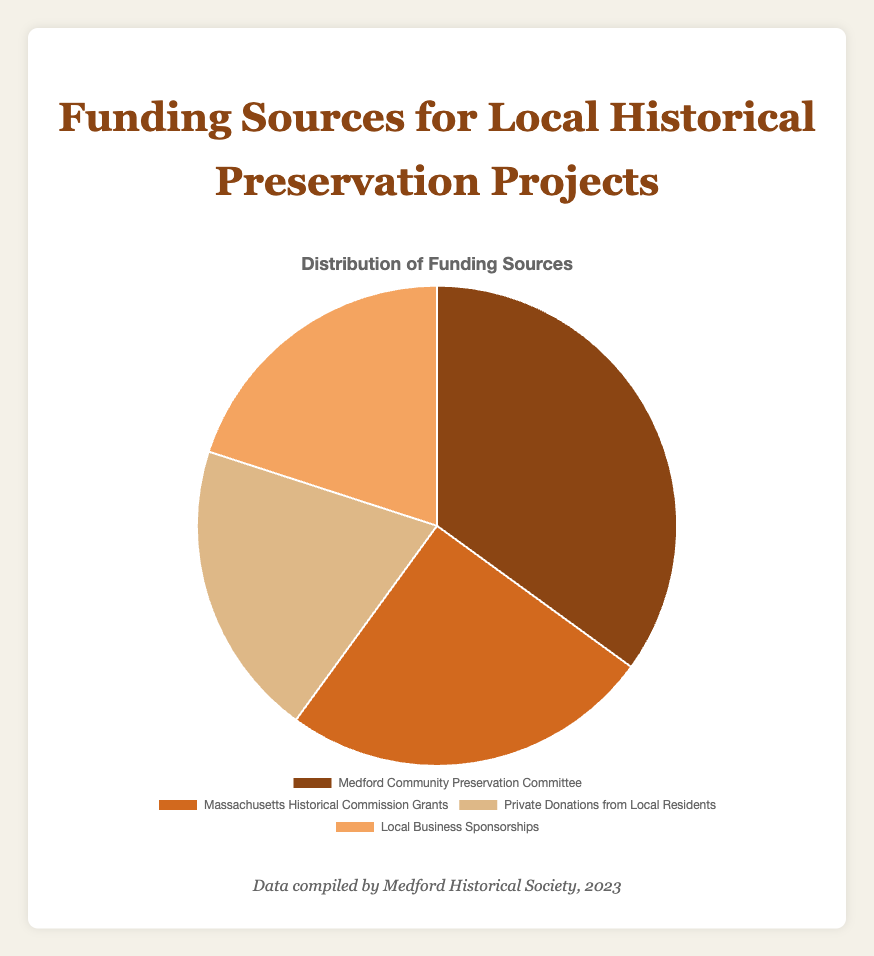What percentage of funding comes from the Massachusetts Historical Commission Grants? The figure shows that the Massachusetts Historical Commission Grants contribute 25% of the funding for local historical preservation projects.
Answer: 25% Which funding source contributes the most to local historical preservation projects? By looking at the pie chart, we see that the Medford Community Preservation Committee contributes 35%, which is the highest percentage among the listed sources.
Answer: Medford Community Preservation Committee Are private donations from local residents equal to the percentage funded by local business sponsorships? The pie chart indicates that both private donations from local residents and local business sponsorships contribute 20% each, so they are equal.
Answer: Yes What is the combined percentage of funding from the Medford Community Preservation Committee and the Massachusetts Historical Commission Grants? The Medford Community Preservation Committee contributes 35% and the Massachusetts Historical Commission Grants contribute 25%. Adding these together, we get 35% + 25% = 60%.
Answer: 60% Which source provides more funding: Private Donations from Local Residents or Massachusetts Historical Commission Grants? The pie chart shows that the Massachusetts Historical Commission Grants provide 25%, which is more than the 20% provided by Private Donations from Local Residents.
Answer: Massachusetts Historical Commission Grants What percentage of funding comes from sources other than the Medford Community Preservation Committee? The total funding percentage is 100%. Subtracting the 35% contributed by the Medford Community Preservation Committee, we get 100% - 35% = 65%.
Answer: 65% What is the average percentage of funding contributed by the four sources? The percentages are 35%, 25%, 20%, and 20%. Adding these together, we get 35 + 25 + 20 + 20 = 100. Dividing by 4, the average is 100/4 = 25%.
Answer: 25% If we combine the contributions from private donations and local business sponsorships, what is the percentage? Private donations from local residents and local business sponsorships both contribute 20%. Adding these together, we get 20% + 20% = 40%.
Answer: 40% Which funding source is represented by the light brown color in the pie chart? The light brown section corresponds to the Medford Community Preservation Committee, which contributes 35% of the funding.
Answer: Medford Community Preservation Committee 